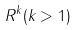<formula> <loc_0><loc_0><loc_500><loc_500>R ^ { k } ( k > 1 )</formula> 